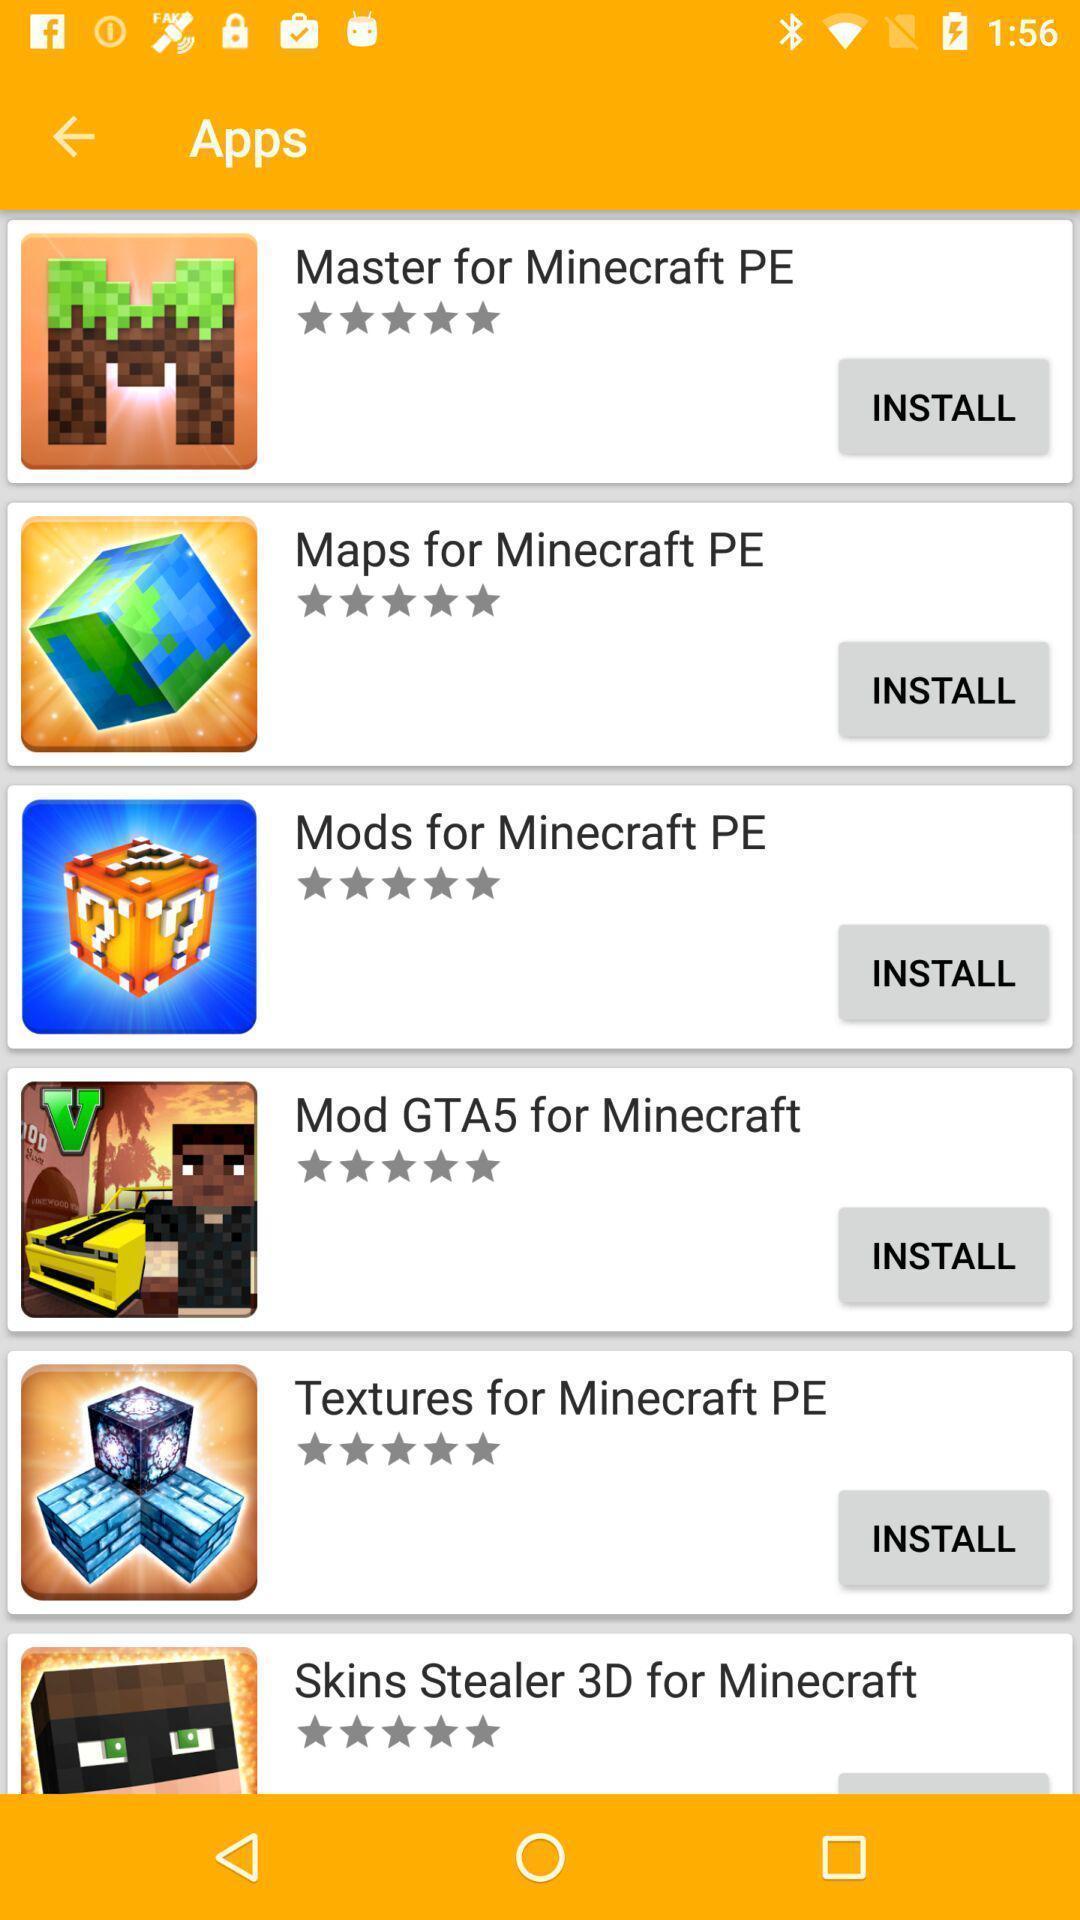Summarize the main components in this picture. Page showing the game applications with install button. 